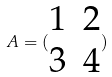<formula> <loc_0><loc_0><loc_500><loc_500>A = ( \begin{matrix} 1 & 2 \\ 3 & 4 \end{matrix} )</formula> 